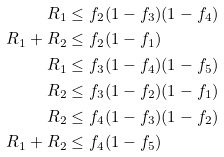Convert formula to latex. <formula><loc_0><loc_0><loc_500><loc_500>R _ { 1 } & \leq f _ { 2 } ( 1 - f _ { 3 } ) ( 1 - f _ { 4 } ) \\ R _ { 1 } + R _ { 2 } & \leq f _ { 2 } ( 1 - f _ { 1 } ) \\ R _ { 1 } & \leq f _ { 3 } ( 1 - f _ { 4 } ) ( 1 - f _ { 5 } ) \\ R _ { 2 } & \leq f _ { 3 } ( 1 - f _ { 2 } ) ( 1 - f _ { 1 } ) \\ R _ { 2 } & \leq f _ { 4 } ( 1 - f _ { 3 } ) ( 1 - f _ { 2 } ) \\ R _ { 1 } + R _ { 2 } & \leq f _ { 4 } ( 1 - f _ { 5 } )</formula> 